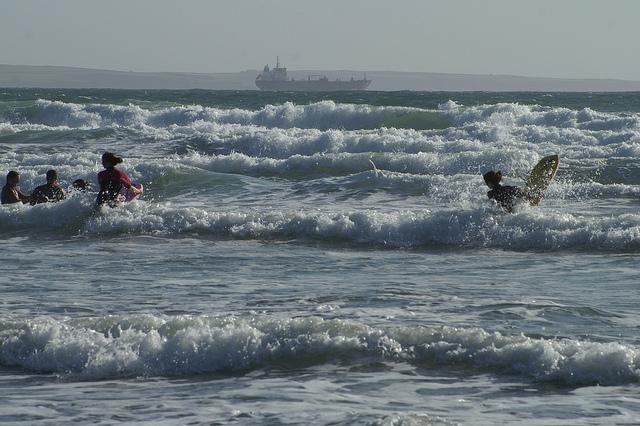What are the people doing on the beach?
Answer briefly. Surfing. How many people are in the water?
Quick response, please. 4. Are the people in the water encountering problems?
Write a very short answer. Yes. How many people in the water?
Write a very short answer. 5. Is anyone swimming?
Concise answer only. Yes. How many people are standing on their board?
Short answer required. 0. Is the man surfing or bodyboarding?
Concise answer only. Bodyboarding. Are these people following the buddy system for swimming?
Keep it brief. Yes. Is the water calm?
Give a very brief answer. No. 